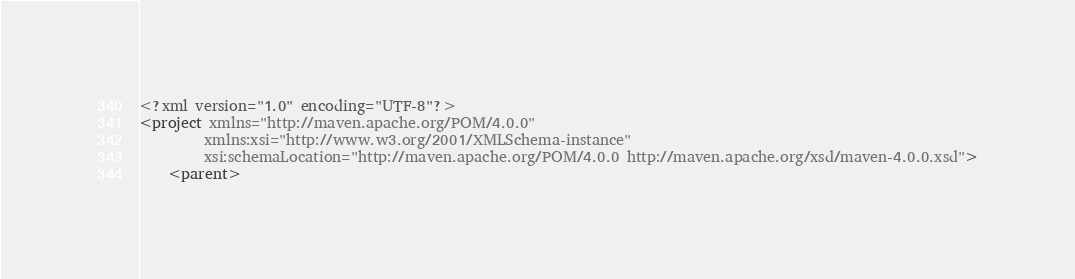Convert code to text. <code><loc_0><loc_0><loc_500><loc_500><_XML_><?xml version="1.0" encoding="UTF-8"?>
<project xmlns="http://maven.apache.org/POM/4.0.0"
         xmlns:xsi="http://www.w3.org/2001/XMLSchema-instance"
         xsi:schemaLocation="http://maven.apache.org/POM/4.0.0 http://maven.apache.org/xsd/maven-4.0.0.xsd">
    <parent></code> 